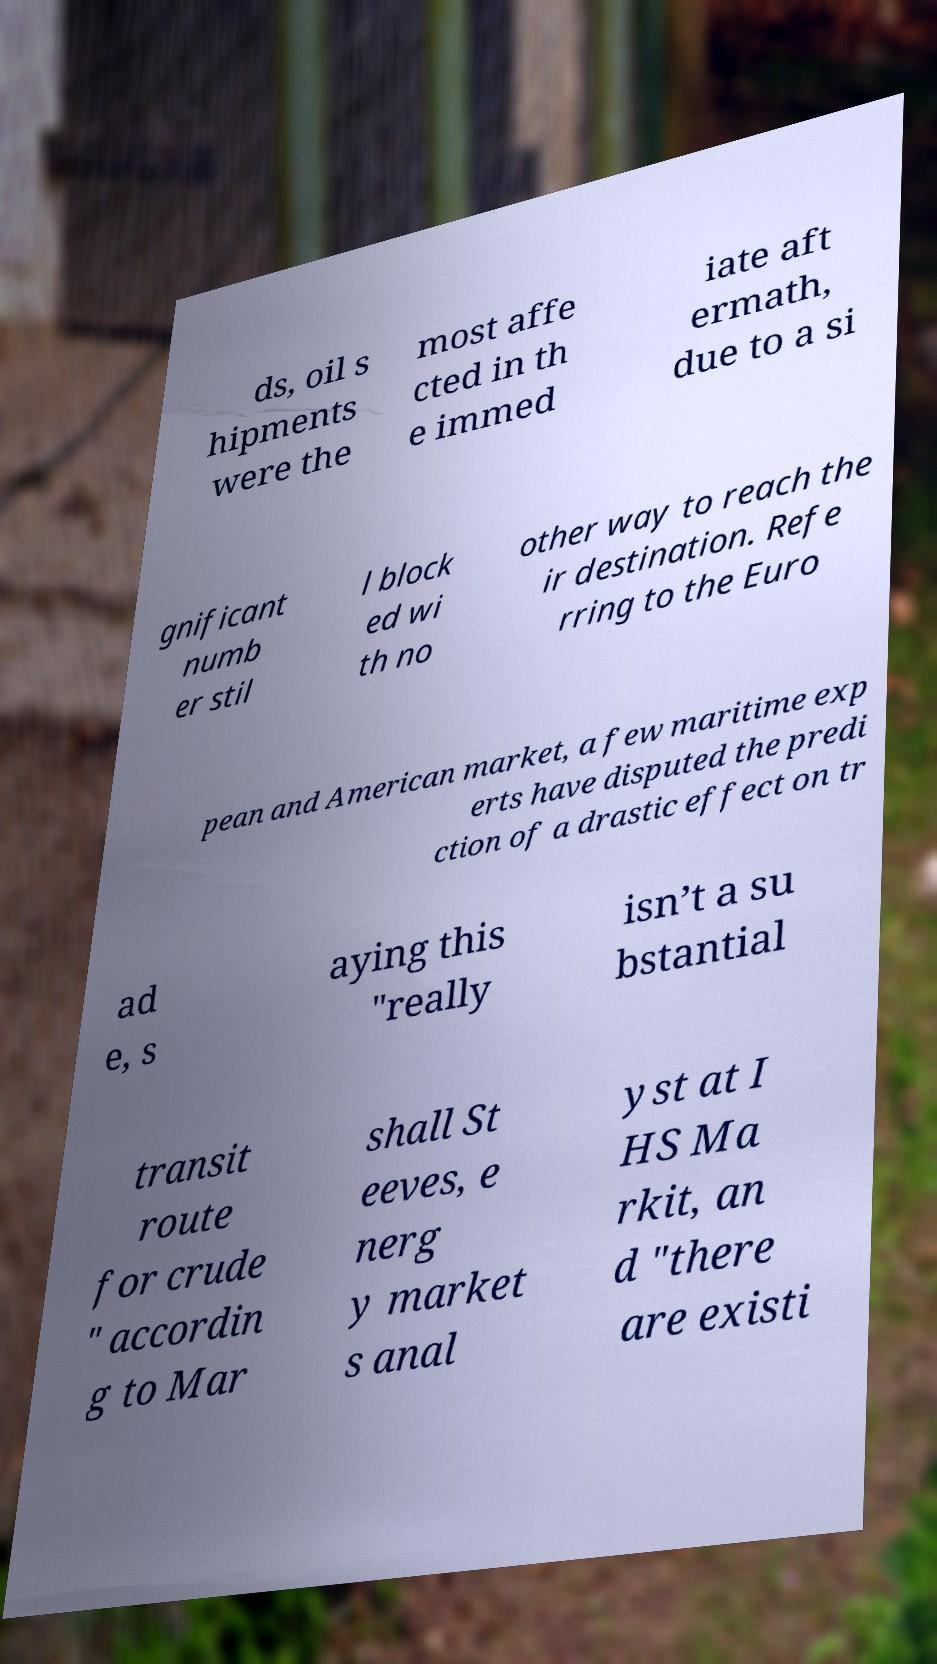What messages or text are displayed in this image? I need them in a readable, typed format. ds, oil s hipments were the most affe cted in th e immed iate aft ermath, due to a si gnificant numb er stil l block ed wi th no other way to reach the ir destination. Refe rring to the Euro pean and American market, a few maritime exp erts have disputed the predi ction of a drastic effect on tr ad e, s aying this "really isn’t a su bstantial transit route for crude " accordin g to Mar shall St eeves, e nerg y market s anal yst at I HS Ma rkit, an d "there are existi 